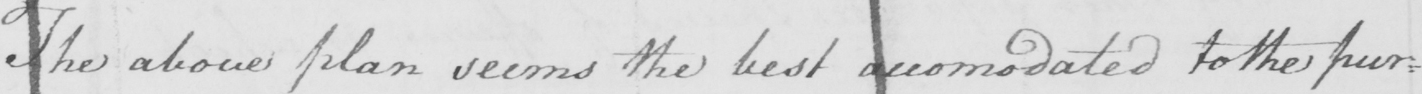Transcribe the text shown in this historical manuscript line. The above plan seems the best accomodated to the pur= 